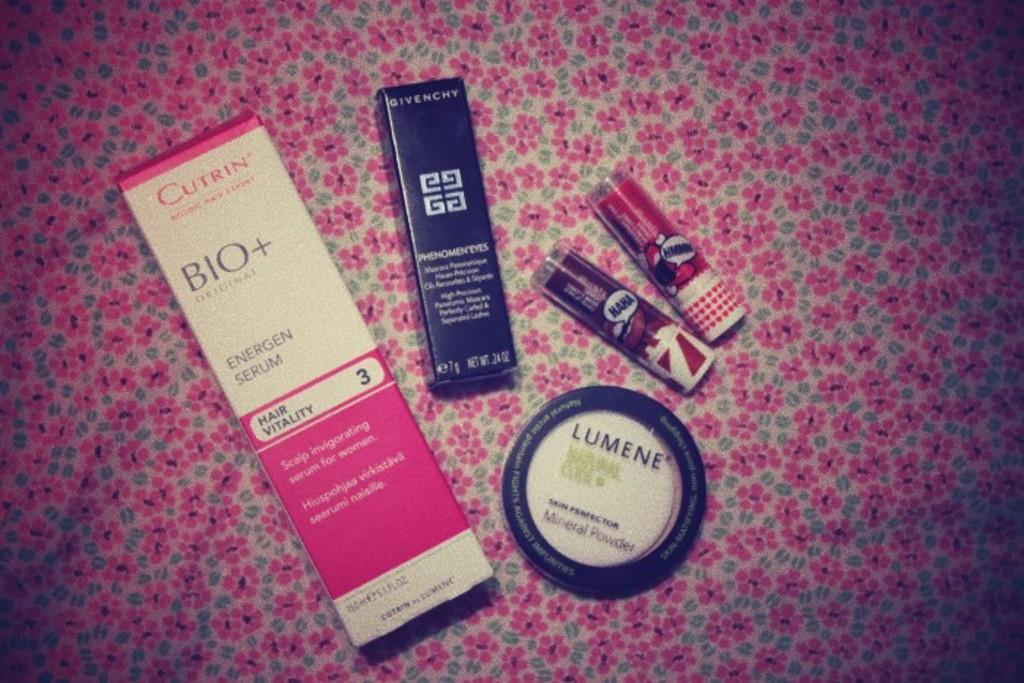<image>
Relay a brief, clear account of the picture shown. Several face products including Lumene, on a floral background 